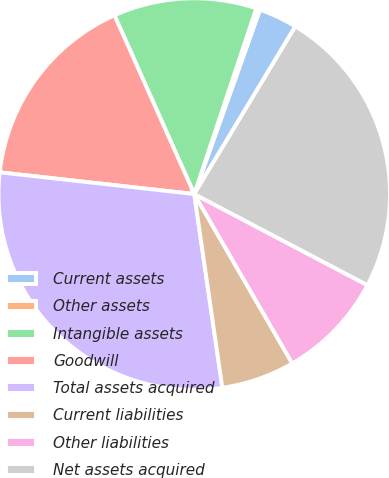Convert chart to OTSL. <chart><loc_0><loc_0><loc_500><loc_500><pie_chart><fcel>Current assets<fcel>Other assets<fcel>Intangible assets<fcel>Goodwill<fcel>Total assets acquired<fcel>Current liabilities<fcel>Other liabilities<fcel>Net assets acquired<nl><fcel>3.19%<fcel>0.32%<fcel>11.81%<fcel>16.55%<fcel>29.06%<fcel>6.06%<fcel>8.94%<fcel>24.07%<nl></chart> 